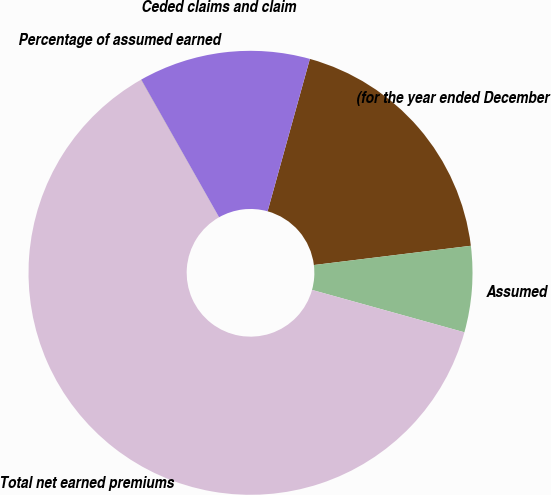Convert chart to OTSL. <chart><loc_0><loc_0><loc_500><loc_500><pie_chart><fcel>(for the year ended December<fcel>Assumed<fcel>Total net earned premiums<fcel>Percentage of assumed earned<fcel>Ceded claims and claim<nl><fcel>18.75%<fcel>6.26%<fcel>62.48%<fcel>0.01%<fcel>12.5%<nl></chart> 